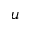<formula> <loc_0><loc_0><loc_500><loc_500>u</formula> 